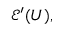Convert formula to latex. <formula><loc_0><loc_0><loc_500><loc_500>{ \mathcal { E } } ^ { \prime } ( U ) ,</formula> 